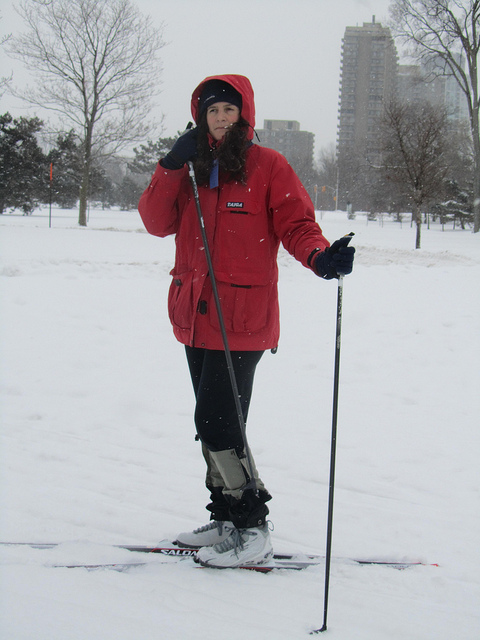Read and extract the text from this image. SALOM 